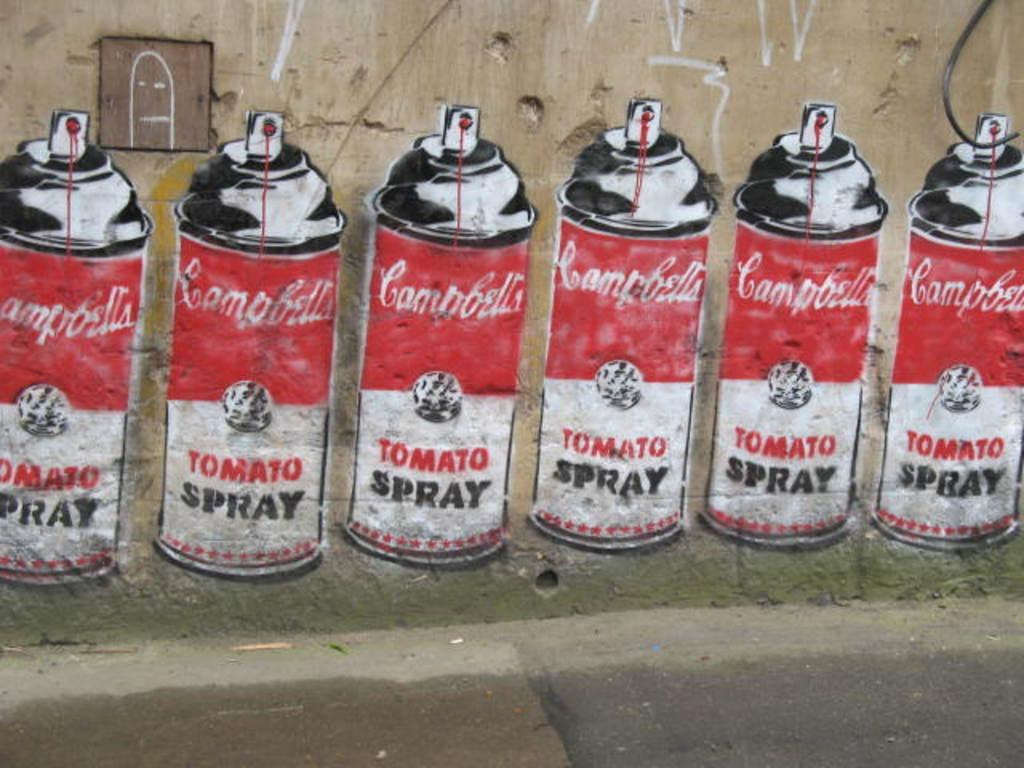Provide a one-sentence caption for the provided image. Six cans of Campbell's Tomato Spray are painted on the wall here. 